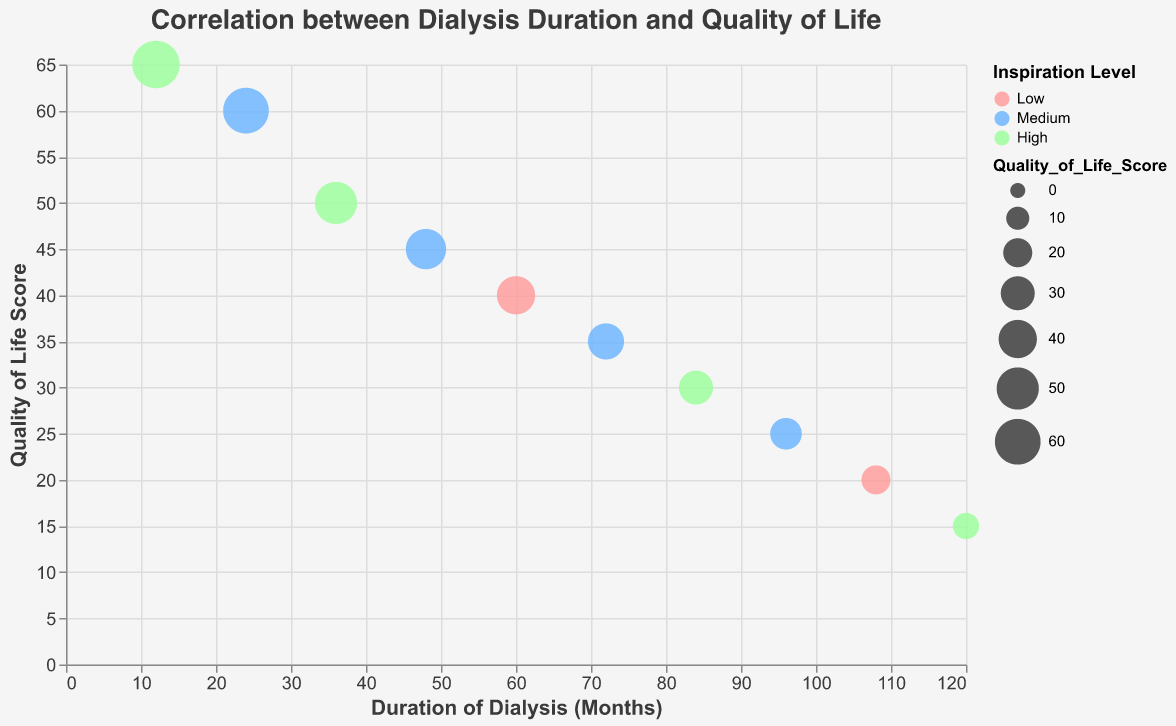What is the title of the chart? The title is displayed at the top of the chart and gives an idea of what the chart is about.
Answer: Correlation between Dialysis Duration and Quality of Life What is the duration of dialysis treatment corresponding to a Quality of Life Score of 35? The location on the y-axis for a Quality of Life Score of 35 and tracing it horizontally to the x-axis for the duration of dialysis treatment provides the answer.
Answer: 72 months How many support groups are represented in the chart? Each bubble represents a different support group. By counting the total number of bubbles in the chart, we find out how many support groups are included.
Answer: 10 Which support group has the highest quality of life score? By identifying the bubble at the highest point on the y-axis, we can determine which support group it represents. Hovering over the bubble likely provides the tooltip with this information.
Answer: Kidney Foundation Is there a trend between the duration of dialysis and the quality of life scores? Observing the bubbles from left to right, we can see if there is an increasing or decreasing trend in the quality of life scores.
Answer: Yes, a decreasing trend What is the average quality of life score for support groups with a High inspiration level? First, identify all bubbles with a "High" inspiration level by their color. Then, sum up their Quality of Life Scores and divide by the number of such bubbles. The bubbles represent scores 65, 50, 30, and 15. Sum = 160, count = 4, 160/4 = 40.
Answer: 40 Compare the inspiration levels of "Kidney Care Advocates" and "Fresenius Kidney Care". Which one is higher? By looking at the color-coded bubbles for each support group and identifying their inspiration levels, we can make a comparison.
Answer: Fresenius Kidney Care Which support group has the lowest quality of life score and what is the duration of dialysis for this group? Identifying the bubble positioned at the lowest point on the y-axis gives us the support group and its corresponding x-axis value for the dialysis duration.
Answer: End-Stage Renal Outreach, 120 months What is the total duration of dialysis treatment for support groups with "Medium" inspiration levels? Identify the bubbles with a "Medium" inspiration level by their color, then sum the corresponding x-axis values. The durations are 24, 48, 72, and 96. Sum = 24 + 48 + 72 + 96 = 240.
Answer: 240 months What is the relationship between dialysis duration and quality of life score for "Renal Warriors"? Locate the bubble representing "Renal Warriors" and observe its x and y coordinates. Check if there's a noticeable pattern in the chart related to the general trend.
Answer: 84 months, 30 quality of life score 